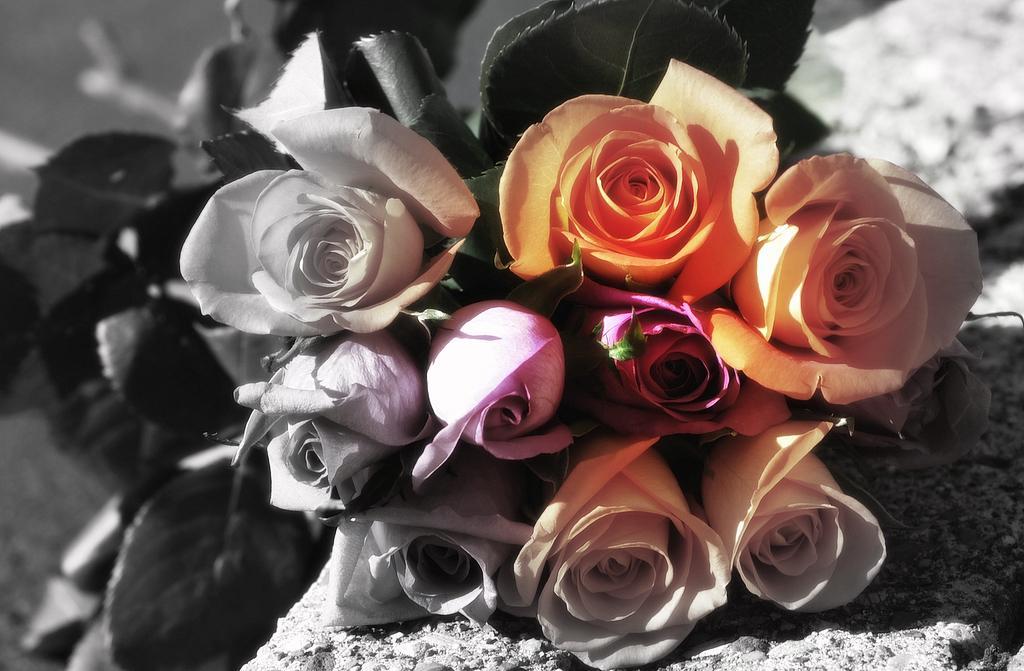Can you describe this image briefly? There is a zoom in picture of a bunch of flowers as we can see in the middle of this image. 